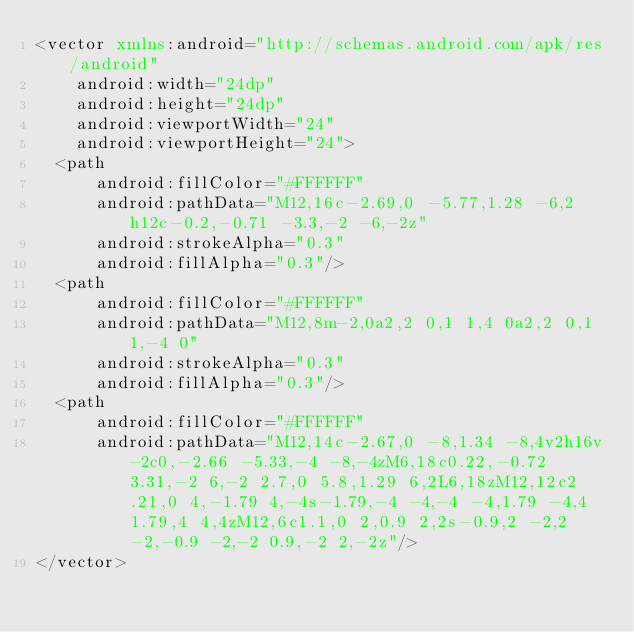<code> <loc_0><loc_0><loc_500><loc_500><_XML_><vector xmlns:android="http://schemas.android.com/apk/res/android"
    android:width="24dp"
    android:height="24dp"
    android:viewportWidth="24"
    android:viewportHeight="24">
  <path
      android:fillColor="#FFFFFF"
      android:pathData="M12,16c-2.69,0 -5.77,1.28 -6,2h12c-0.2,-0.71 -3.3,-2 -6,-2z"
      android:strokeAlpha="0.3"
      android:fillAlpha="0.3"/>
  <path
      android:fillColor="#FFFFFF"
      android:pathData="M12,8m-2,0a2,2 0,1 1,4 0a2,2 0,1 1,-4 0"
      android:strokeAlpha="0.3"
      android:fillAlpha="0.3"/>
  <path
      android:fillColor="#FFFFFF"
      android:pathData="M12,14c-2.67,0 -8,1.34 -8,4v2h16v-2c0,-2.66 -5.33,-4 -8,-4zM6,18c0.22,-0.72 3.31,-2 6,-2 2.7,0 5.8,1.29 6,2L6,18zM12,12c2.21,0 4,-1.79 4,-4s-1.79,-4 -4,-4 -4,1.79 -4,4 1.79,4 4,4zM12,6c1.1,0 2,0.9 2,2s-0.9,2 -2,2 -2,-0.9 -2,-2 0.9,-2 2,-2z"/>
</vector>
</code> 